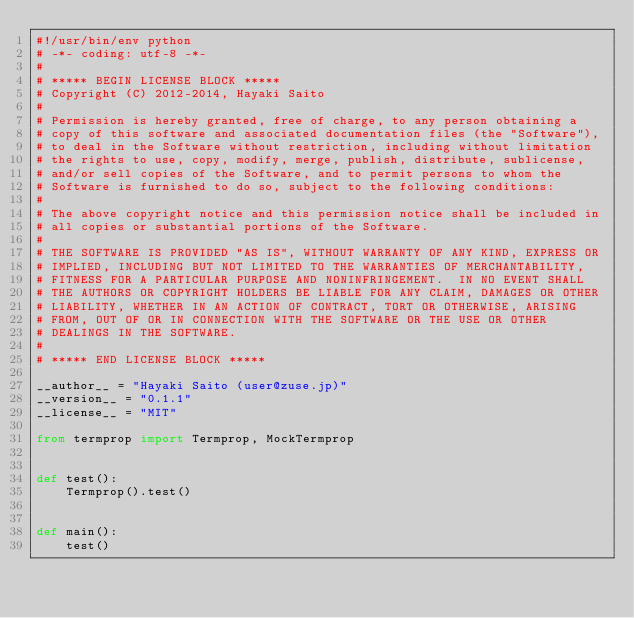<code> <loc_0><loc_0><loc_500><loc_500><_Python_>#!/usr/bin/env python
# -*- coding: utf-8 -*-
#
# ***** BEGIN LICENSE BLOCK *****
# Copyright (C) 2012-2014, Hayaki Saito 
# 
# Permission is hereby granted, free of charge, to any person obtaining a 
# copy of this software and associated documentation files (the "Software"), 
# to deal in the Software without restriction, including without limitation 
# the rights to use, copy, modify, merge, publish, distribute, sublicense, 
# and/or sell copies of the Software, and to permit persons to whom the 
# Software is furnished to do so, subject to the following conditions: 
# 
# The above copyright notice and this permission notice shall be included in 
# all copies or substantial portions of the Software. 
# 
# THE SOFTWARE IS PROVIDED "AS IS", WITHOUT WARRANTY OF ANY KIND, EXPRESS OR 
# IMPLIED, INCLUDING BUT NOT LIMITED TO THE WARRANTIES OF MERCHANTABILITY, 
# FITNESS FOR A PARTICULAR PURPOSE AND NONINFRINGEMENT.  IN NO EVENT SHALL 
# THE AUTHORS OR COPYRIGHT HOLDERS BE LIABLE FOR ANY CLAIM, DAMAGES OR OTHER 
# LIABILITY, WHETHER IN AN ACTION OF CONTRACT, TORT OR OTHERWISE, ARISING 
# FROM, OUT OF OR IN CONNECTION WITH THE SOFTWARE OR THE USE OR OTHER 
# DEALINGS IN THE SOFTWARE. 
# 
# ***** END LICENSE BLOCK *****

__author__ = "Hayaki Saito (user@zuse.jp)"
__version__ = "0.1.1"
__license__ = "MIT"

from termprop import Termprop, MockTermprop


def test():
    Termprop().test()


def main():
    test()
</code> 